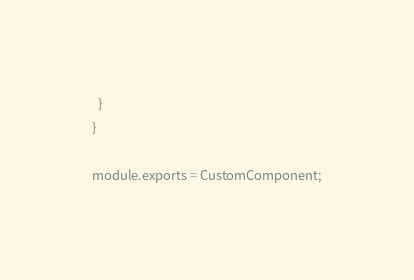Convert code to text. <code><loc_0><loc_0><loc_500><loc_500><_JavaScript_>  }
}

module.exports = CustomComponent;</code> 